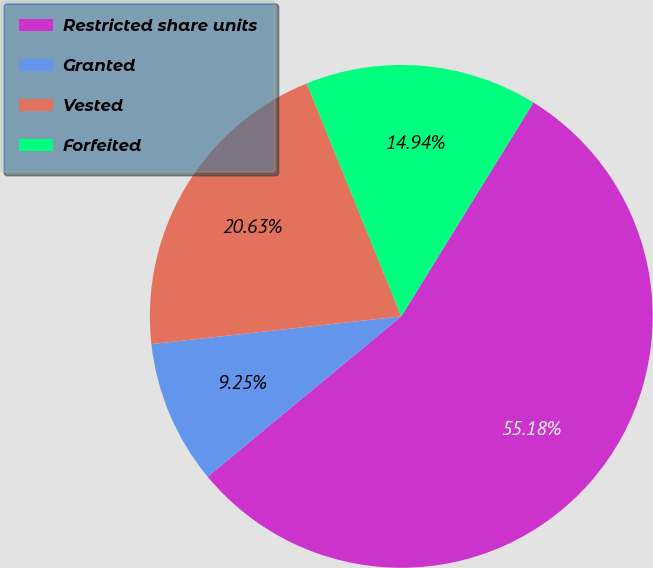Convert chart. <chart><loc_0><loc_0><loc_500><loc_500><pie_chart><fcel>Restricted share units<fcel>Granted<fcel>Vested<fcel>Forfeited<nl><fcel>55.18%<fcel>9.25%<fcel>20.63%<fcel>14.94%<nl></chart> 